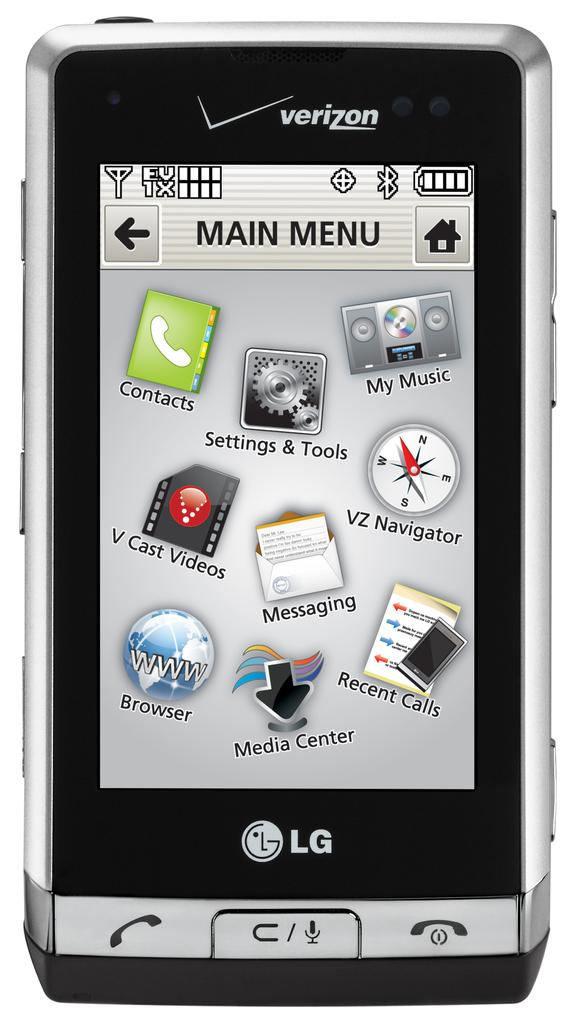<image>
Share a concise interpretation of the image provided. A verizon supported LG phone with the main menu on the screen. 